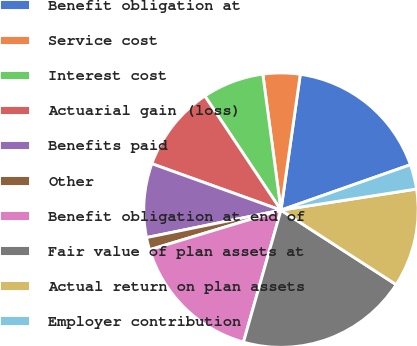Convert chart to OTSL. <chart><loc_0><loc_0><loc_500><loc_500><pie_chart><fcel>Benefit obligation at<fcel>Service cost<fcel>Interest cost<fcel>Actuarial gain (loss)<fcel>Benefits paid<fcel>Other<fcel>Benefit obligation at end of<fcel>Fair value of plan assets at<fcel>Actual return on plan assets<fcel>Employer contribution<nl><fcel>17.38%<fcel>4.36%<fcel>7.25%<fcel>10.14%<fcel>8.7%<fcel>1.46%<fcel>15.93%<fcel>20.27%<fcel>11.59%<fcel>2.91%<nl></chart> 